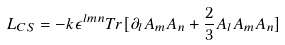<formula> <loc_0><loc_0><loc_500><loc_500>L _ { C S } = - k \epsilon ^ { l m n } T r [ \partial _ { l } A _ { m } A _ { n } + \frac { 2 } { 3 } A _ { l } A _ { m } A _ { n } ]</formula> 